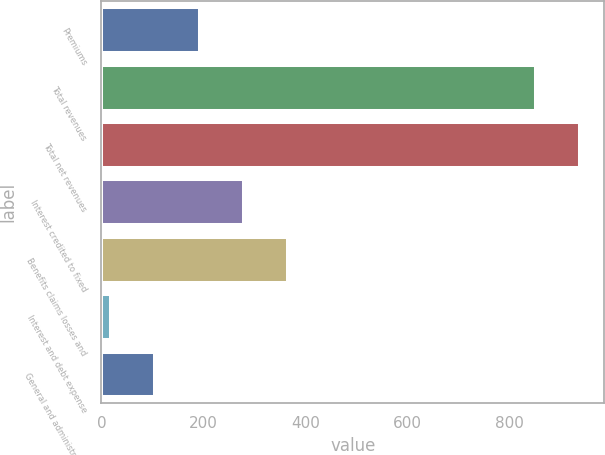Convert chart. <chart><loc_0><loc_0><loc_500><loc_500><bar_chart><fcel>Premiums<fcel>Total revenues<fcel>Total net revenues<fcel>Interest credited to fixed<fcel>Benefits claims losses and<fcel>Interest and debt expense<fcel>General and administrative<nl><fcel>192.2<fcel>851<fcel>938.1<fcel>279.3<fcel>366.4<fcel>18<fcel>105.1<nl></chart> 